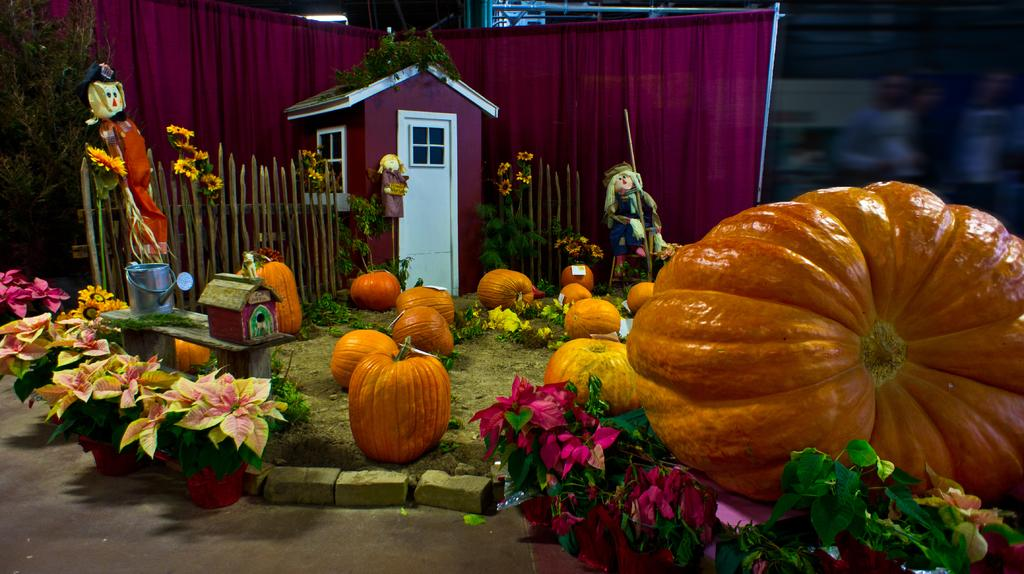What types of objects can be seen in the image? There are toys, pumpkins, and flowers in the image. Can you describe any other objects present in the image? Yes, there are other objects in the image. What type of scarf is draped over the bear in the image? There is no bear or scarf present in the image. Can you see any steam coming from the objects in the image? There is no steam visible in the image. 